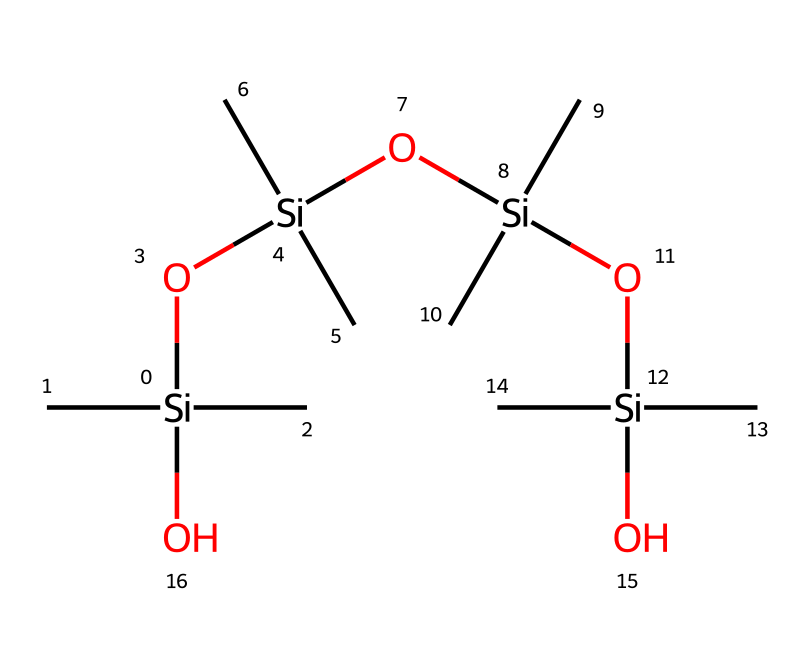What is the central atom of this polysiloxane structure? The SMILES representation indicates the presence of silicon atoms, which function as the central framework of the polysiloxane chains.
Answer: silicon How many silicon atoms are present in this structure? By counting the silicon atoms in the SMILES representation, I can identify a total of five silicon atoms.
Answer: five What is the primary type of bonding present in this compound? The structure indicates that the primary bonding in polysiloxanes is silicon-oxygen bonds, as seen in the repeating units.
Answer: silicon-oxygen How many oxygen atoms are there in this polysiloxane? The SMILES representation shows four oxygen atoms that link the silicon atoms in the polymer chain.
Answer: four What functional groups are present in this organosilicon compound? This compound primarily consists of hydroxy groups (–OH) attached to silicon, evident from the structure.
Answer: hydroxy Why is this chemical suitable for insulation materials? The long, flexible siloxane chains provide excellent thermal and electrical insulating properties due to their high stability and low thermal conductivity.
Answer: excellent thermal and electrical insulating properties How does the branching in the structure affect its properties? The branching allows for flexibility and enhanced alignment of the siloxane chains, improving its mechanical properties and resistance to cold flow.
Answer: flexibility and enhanced alignment 